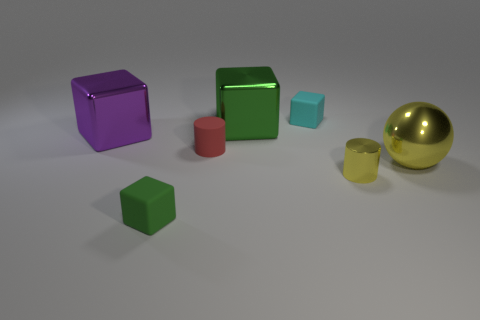Do the yellow metal sphere and the purple metal thing have the same size?
Give a very brief answer. Yes. The small cylinder in front of the small red object is what color?
Make the answer very short. Yellow. Is there a big object that has the same color as the big ball?
Provide a short and direct response. No. There is a matte cylinder that is the same size as the metallic cylinder; what is its color?
Your answer should be compact. Red. Does the big purple thing have the same shape as the small green object?
Give a very brief answer. Yes. What is the green thing that is behind the tiny yellow metallic cylinder made of?
Your answer should be compact. Metal. What color is the shiny cylinder?
Offer a very short reply. Yellow. There is a matte block that is on the right side of the red thing; is it the same size as the green block behind the metal cylinder?
Keep it short and to the point. No. There is a thing that is both on the left side of the tiny shiny cylinder and on the right side of the green shiny block; what size is it?
Provide a succinct answer. Small. There is another big object that is the same shape as the purple thing; what is its color?
Give a very brief answer. Green. 